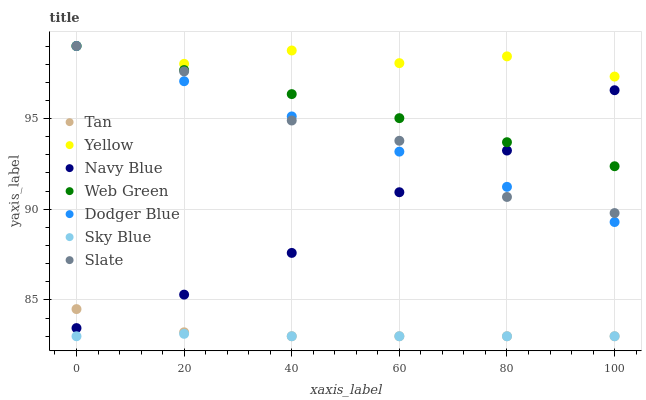Does Sky Blue have the minimum area under the curve?
Answer yes or no. Yes. Does Yellow have the maximum area under the curve?
Answer yes or no. Yes. Does Slate have the minimum area under the curve?
Answer yes or no. No. Does Slate have the maximum area under the curve?
Answer yes or no. No. Is Dodger Blue the smoothest?
Answer yes or no. Yes. Is Slate the roughest?
Answer yes or no. Yes. Is Web Green the smoothest?
Answer yes or no. No. Is Web Green the roughest?
Answer yes or no. No. Does Sky Blue have the lowest value?
Answer yes or no. Yes. Does Slate have the lowest value?
Answer yes or no. No. Does Yellow have the highest value?
Answer yes or no. Yes. Does Sky Blue have the highest value?
Answer yes or no. No. Is Sky Blue less than Navy Blue?
Answer yes or no. Yes. Is Yellow greater than Sky Blue?
Answer yes or no. Yes. Does Web Green intersect Yellow?
Answer yes or no. Yes. Is Web Green less than Yellow?
Answer yes or no. No. Is Web Green greater than Yellow?
Answer yes or no. No. Does Sky Blue intersect Navy Blue?
Answer yes or no. No. 